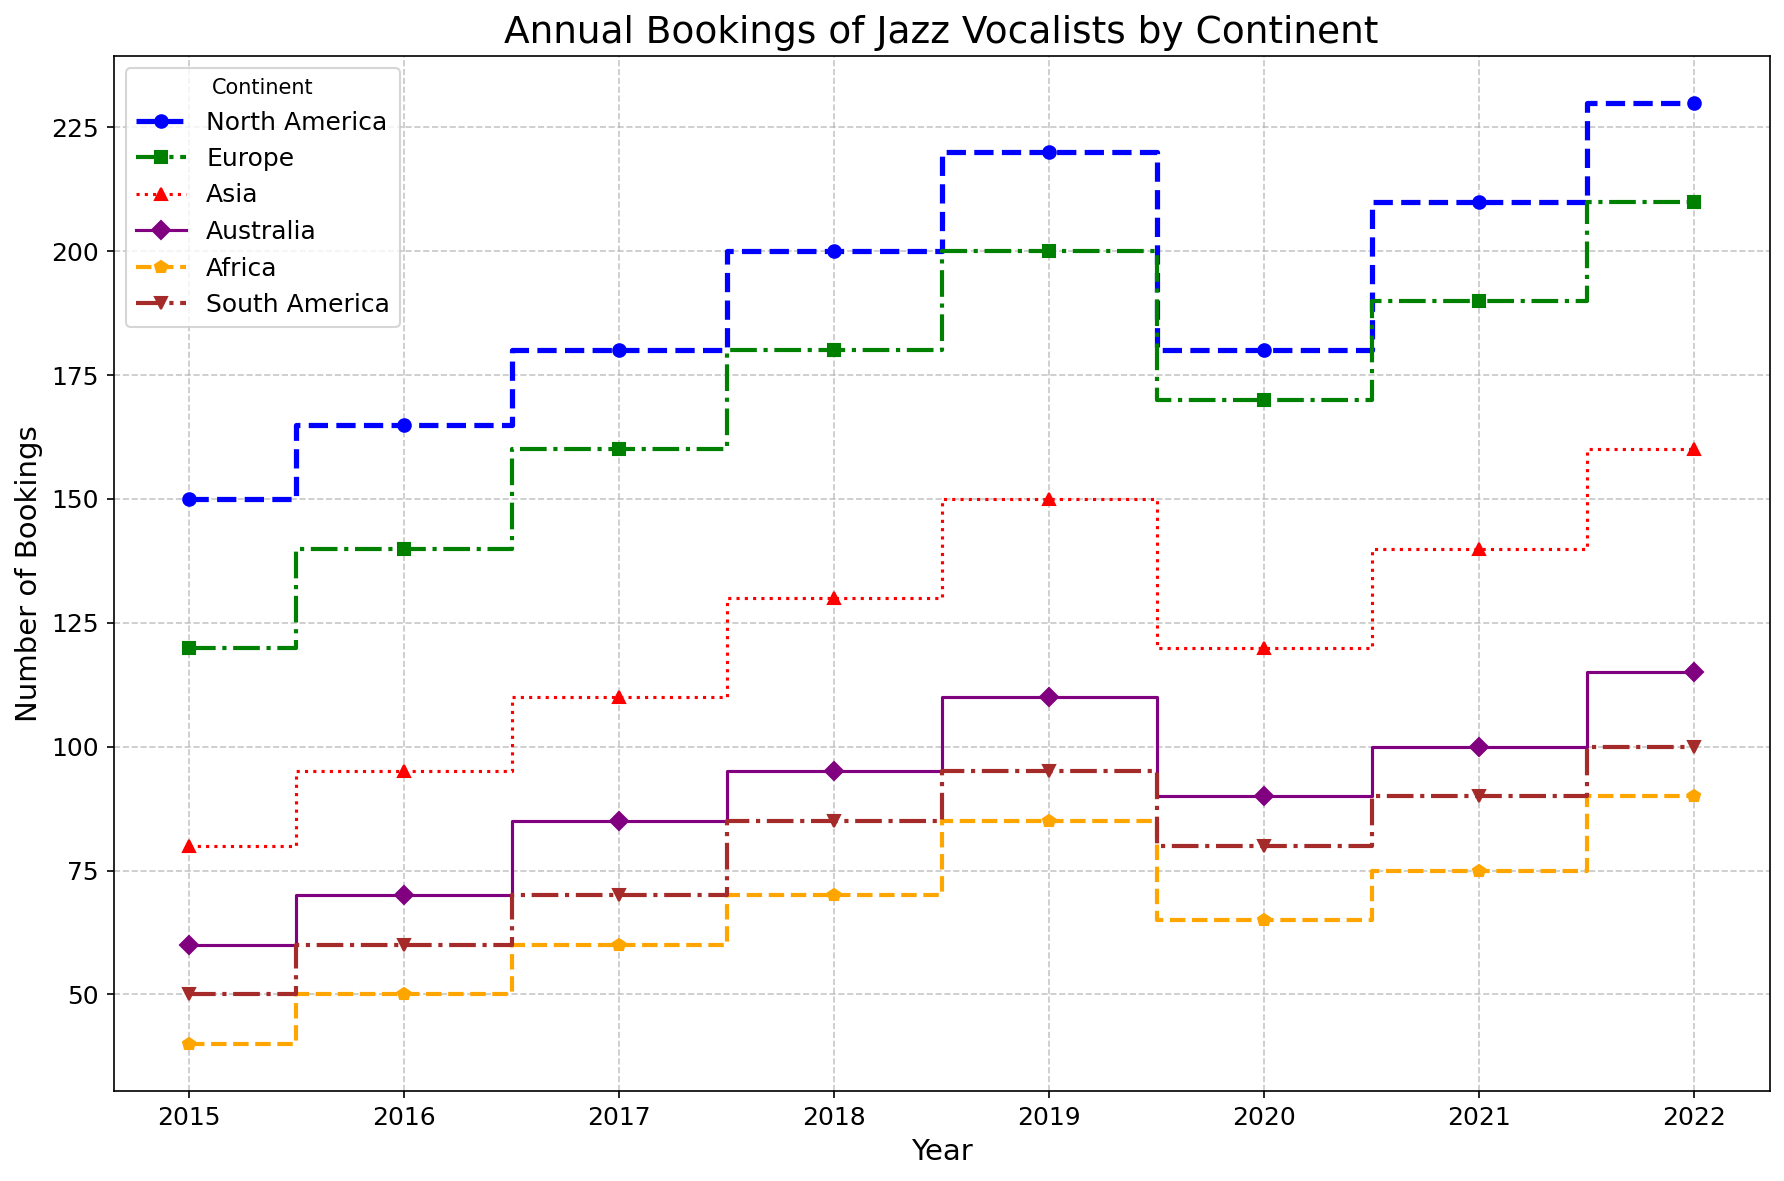Which continent has the highest number of bookings in 2022? Look at the data points at 2022 for each continent and compare their heights. North America has the highest bookings of 230.
Answer: North America How did the bookings for North America change from 2019 to 2020? Observe the drop in the plot for North America between 2019 and 2020. The bookings decreased from 220 to 180.
Answer: Decreased Which two continents had exactly 210 bookings in any year? Identify the continents for each year with 210 bookings. Both North America and Europe reached 210.
Answer: North America and Europe In which year did Europe and Asia both have 180 bookings? Examine the plot for the years where Europe and Asia meet at the same height of 180. That year is 2019.
Answer: 2019 How did the booking trend change for Australia from 2015 to 2022? Follow the Australian plot line from 2015 to 2022. The bookings increased steadily over the years from 60 to 115, with a slight dip in 2020.
Answer: Increased What was the booking difference between Africa and South America in 2016? Compare the booking heights for Africa and South America in 2016. Africa had 50 bookings, while South America had 60, yielding a difference of 10.
Answer: 10 Which continent showed the most significant decline in bookings in 2020? Analyze the plot for each continent from 2019 to 2020. North America dropped from 220 to 180, the largest decline.
Answer: North America How did the trend of bookings from 2017 to 2019 differ between Asia and Africa? Observe Asia and Africa's plots from 2017 to 2019. Asia steadily increased from 110 to 150, while Africa increased from 60 to 85.
Answer: Both increased, Asia more steadily Which continent has the most consistent year-to-year booking increments? Check the steadiness of the plot increments for each continent. Europe shows a steady increase each year without large fluctuations.
Answer: Europe On average, how many more bookings did Europe have compared to Africa in 2018? Find the bookings for Europe and Africa in 2018 (180 and 70). The difference is 110. To find the average difference over the year, 110 / 1 = 110.
Answer: 110 